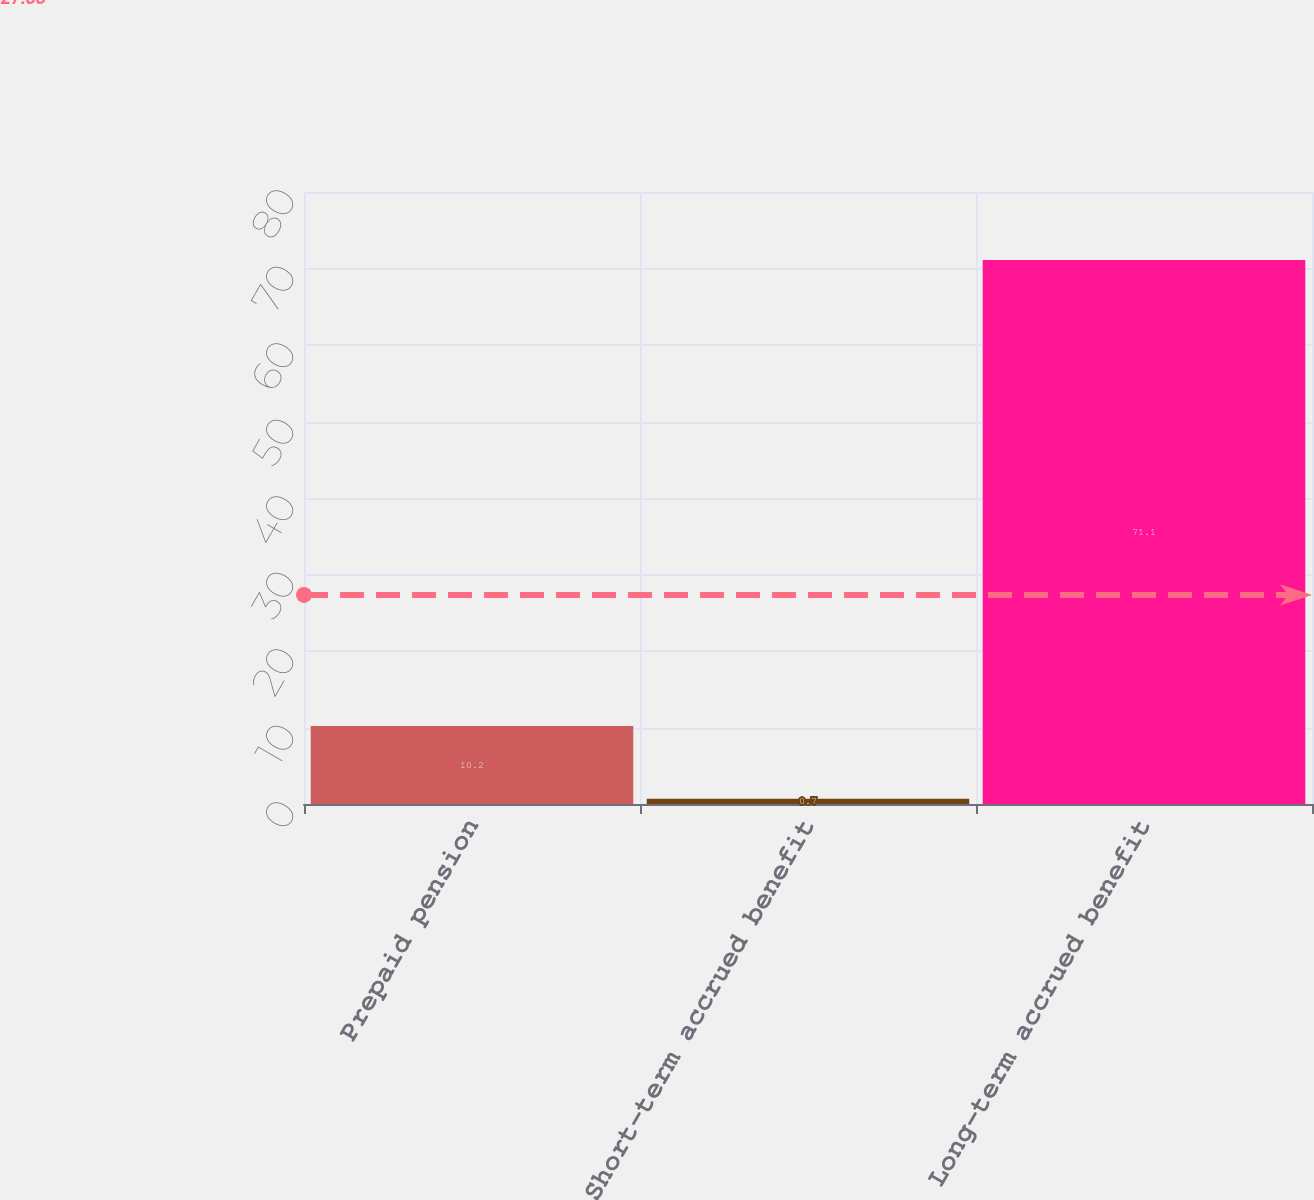<chart> <loc_0><loc_0><loc_500><loc_500><bar_chart><fcel>Prepaid pension<fcel>Short-term accrued benefit<fcel>Long-term accrued benefit<nl><fcel>10.2<fcel>0.7<fcel>71.1<nl></chart> 